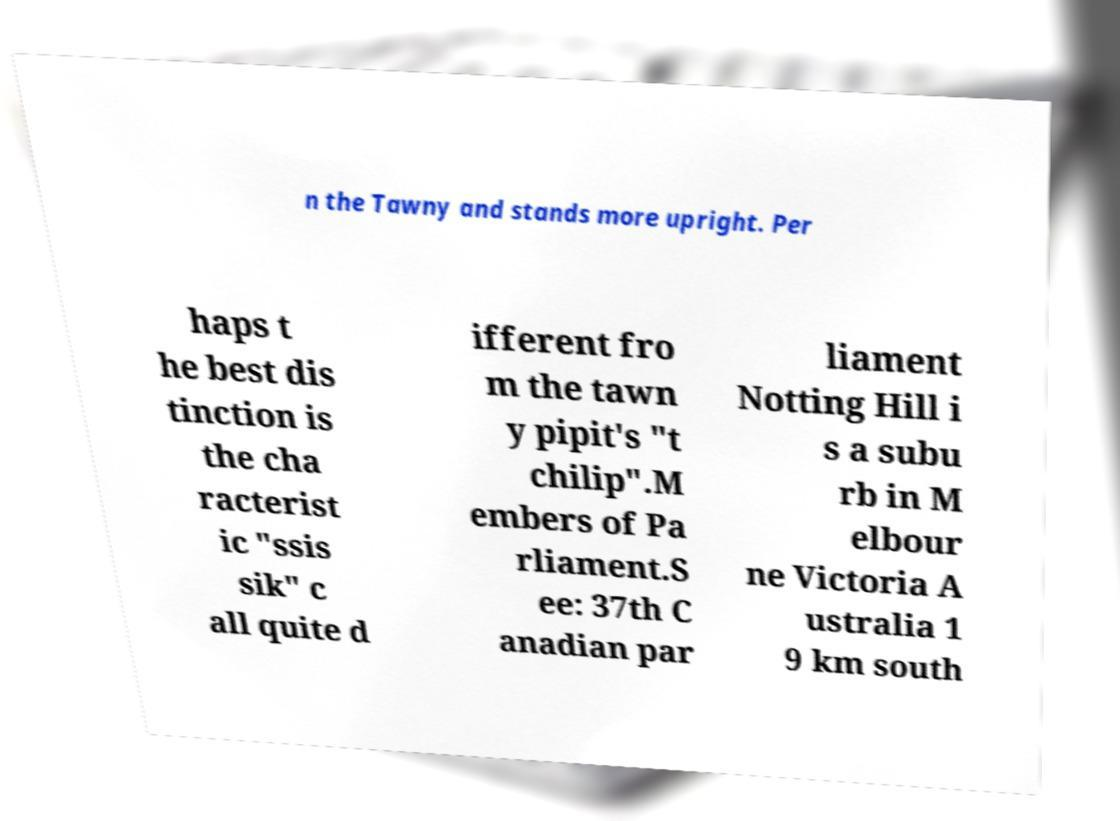Can you read and provide the text displayed in the image?This photo seems to have some interesting text. Can you extract and type it out for me? n the Tawny and stands more upright. Per haps t he best dis tinction is the cha racterist ic "ssis sik" c all quite d ifferent fro m the tawn y pipit's "t chilip".M embers of Pa rliament.S ee: 37th C anadian par liament Notting Hill i s a subu rb in M elbour ne Victoria A ustralia 1 9 km south 